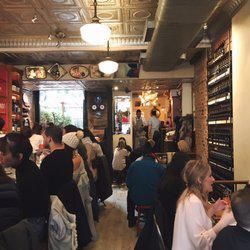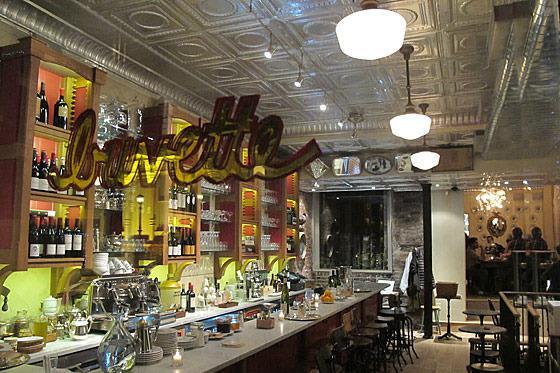The first image is the image on the left, the second image is the image on the right. For the images displayed, is the sentence "In one image, shelves of bottles are behind multiple bartenders in white shirts with neckties, who stand in front of a bar counter." factually correct? Answer yes or no. No. The first image is the image on the left, the second image is the image on the right. Assess this claim about the two images: "There are at least  three bartender with white shirt and ties serving customers from behind the bar.". Correct or not? Answer yes or no. No. 